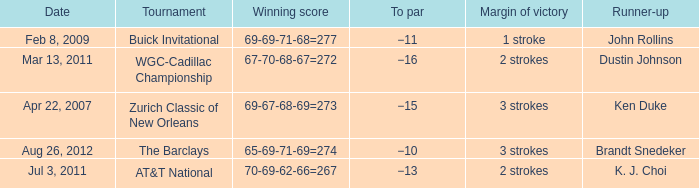What was the to par of the tournament that had Ken Duke as a runner-up? −15. 